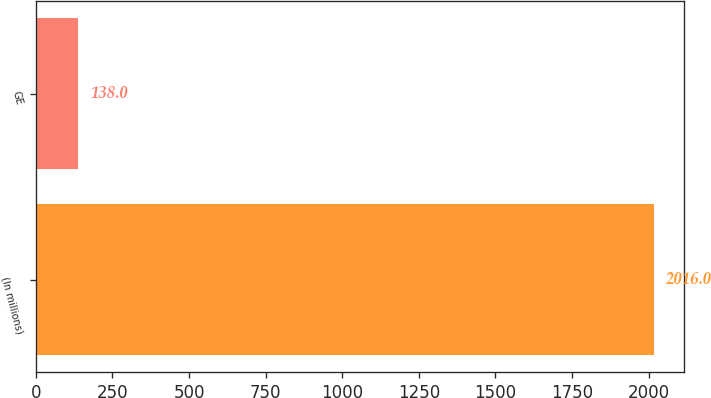Convert chart. <chart><loc_0><loc_0><loc_500><loc_500><bar_chart><fcel>(In millions)<fcel>GE<nl><fcel>2016<fcel>138<nl></chart> 